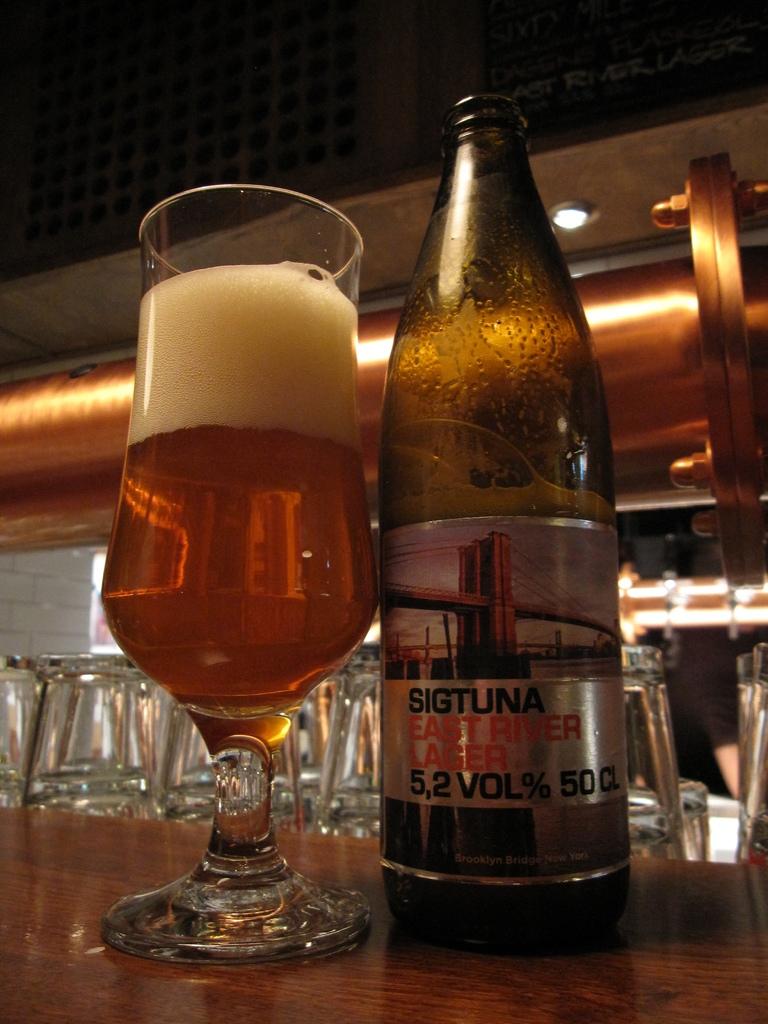Is the alcohol less than 6%?
Ensure brevity in your answer.  Yes. 